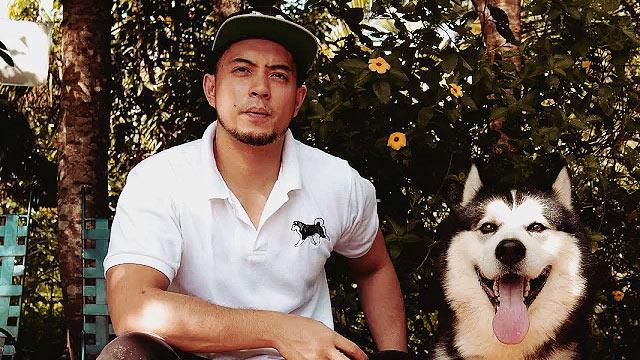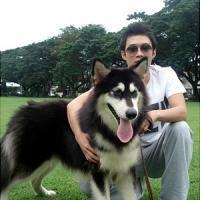The first image is the image on the left, the second image is the image on the right. Examine the images to the left and right. Is the description "The combined images include at least two husky dogs, with at least one black-and-white, and one standing with tongue out and a man kneeling behind it." accurate? Answer yes or no. Yes. The first image is the image on the left, the second image is the image on the right. Evaluate the accuracy of this statement regarding the images: "The right image contains one human interacting with at least one dog.". Is it true? Answer yes or no. Yes. 